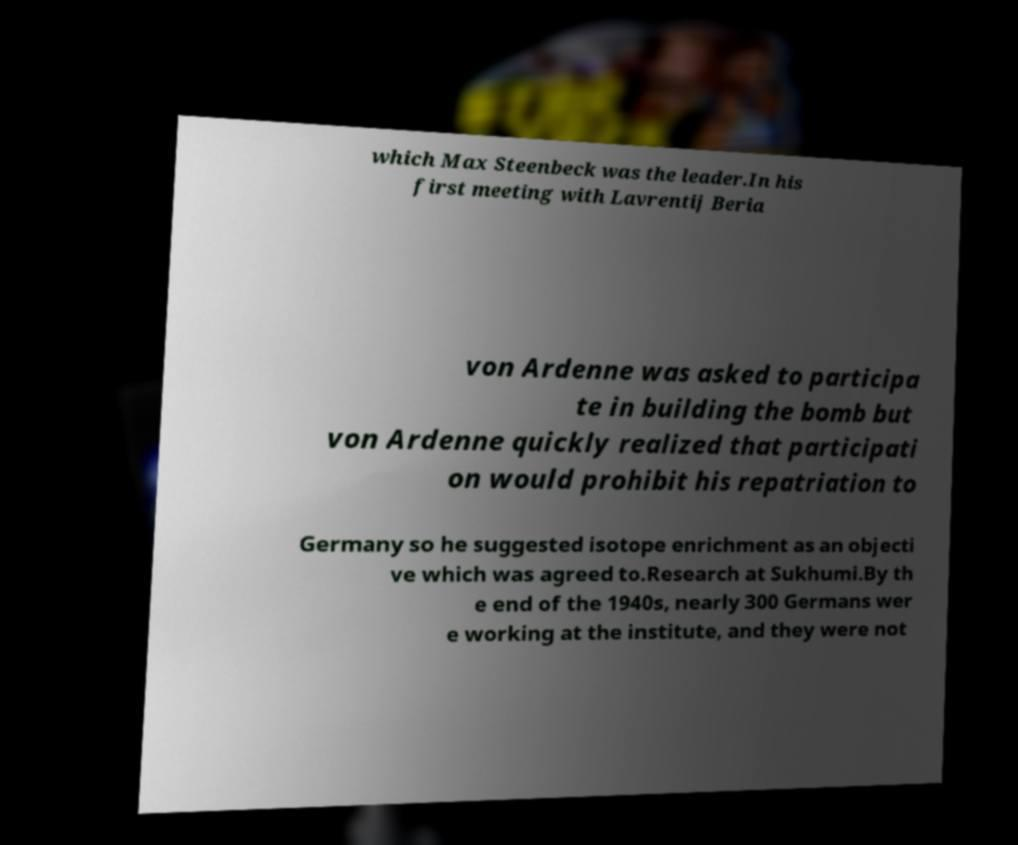There's text embedded in this image that I need extracted. Can you transcribe it verbatim? which Max Steenbeck was the leader.In his first meeting with Lavrentij Beria von Ardenne was asked to participa te in building the bomb but von Ardenne quickly realized that participati on would prohibit his repatriation to Germany so he suggested isotope enrichment as an objecti ve which was agreed to.Research at Sukhumi.By th e end of the 1940s, nearly 300 Germans wer e working at the institute, and they were not 